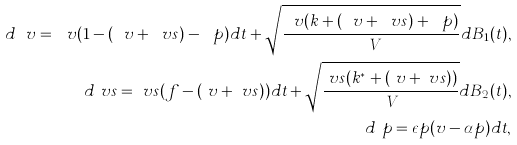<formula> <loc_0><loc_0><loc_500><loc_500>d \ v = \ v ( 1 - ( \ v + \ v s ) - \ p ) d t + \sqrt { \frac { \ v ( k + ( \ v + \ v s ) + \ p ) } { \ V } } d B _ { 1 } ( t ) , \\ d \ v s = \ v s ( f - ( \ v + \ v s ) ) d t + \sqrt { \frac { \ v s ( k ^ { * } + ( \ v + \ v s ) ) } { \ V } } d B _ { 2 } ( t ) , \\ d \ p = \epsilon p ( v - \alpha p ) d t ,</formula> 